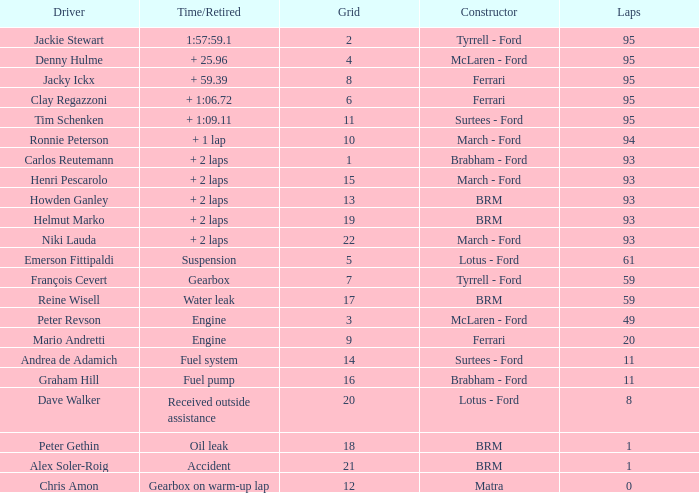What is the lowest grid with matra as constructor? 12.0. 